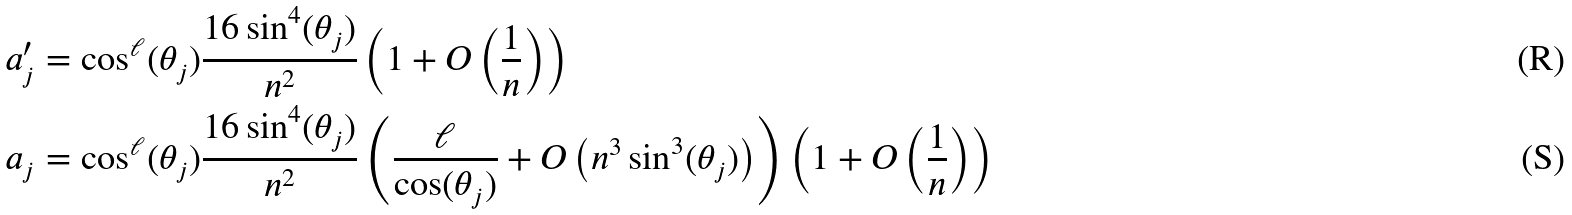Convert formula to latex. <formula><loc_0><loc_0><loc_500><loc_500>a _ { j } ^ { \prime } & = \cos ^ { \ell } ( \theta _ { j } ) \frac { 1 6 \sin ^ { 4 } ( \theta _ { j } ) } { n ^ { 2 } } \left ( 1 + O \left ( \frac { 1 } { n } \right ) \right ) \\ a _ { j } & = \cos ^ { \ell } ( \theta _ { j } ) \frac { 1 6 \sin ^ { 4 } ( \theta _ { j } ) } { n ^ { 2 } } \left ( \frac { \ell } { \cos ( \theta _ { j } ) } + O \left ( n ^ { 3 } \sin ^ { 3 } ( \theta _ { j } ) \right ) \right ) \left ( 1 + O \left ( \frac { 1 } { n } \right ) \right )</formula> 